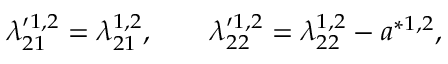<formula> <loc_0><loc_0><loc_500><loc_500>\lambda _ { 2 1 } ^ { \prime 1 , 2 } = \lambda _ { 2 1 } ^ { 1 , 2 } , \quad \lambda _ { 2 2 } ^ { \prime 1 , 2 } = \lambda _ { 2 2 } ^ { 1 , 2 } - a ^ { \ast 1 , 2 } ,</formula> 